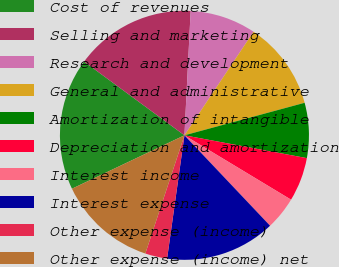Convert chart. <chart><loc_0><loc_0><loc_500><loc_500><pie_chart><fcel>Cost of revenues<fcel>Selling and marketing<fcel>Research and development<fcel>General and administrative<fcel>Amortization of intangible<fcel>Depreciation and amortization<fcel>Interest income<fcel>Interest expense<fcel>Other expense (income)<fcel>Other expense (income) net<nl><fcel>17.14%<fcel>15.71%<fcel>8.57%<fcel>11.43%<fcel>7.14%<fcel>5.71%<fcel>4.29%<fcel>14.29%<fcel>2.86%<fcel>12.86%<nl></chart> 